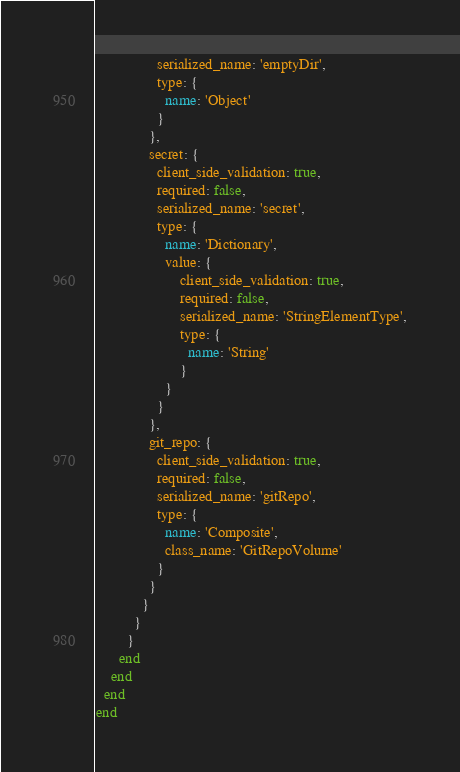Convert code to text. <code><loc_0><loc_0><loc_500><loc_500><_Ruby_>                serialized_name: 'emptyDir',
                type: {
                  name: 'Object'
                }
              },
              secret: {
                client_side_validation: true,
                required: false,
                serialized_name: 'secret',
                type: {
                  name: 'Dictionary',
                  value: {
                      client_side_validation: true,
                      required: false,
                      serialized_name: 'StringElementType',
                      type: {
                        name: 'String'
                      }
                  }
                }
              },
              git_repo: {
                client_side_validation: true,
                required: false,
                serialized_name: 'gitRepo',
                type: {
                  name: 'Composite',
                  class_name: 'GitRepoVolume'
                }
              }
            }
          }
        }
      end
    end
  end
end
</code> 